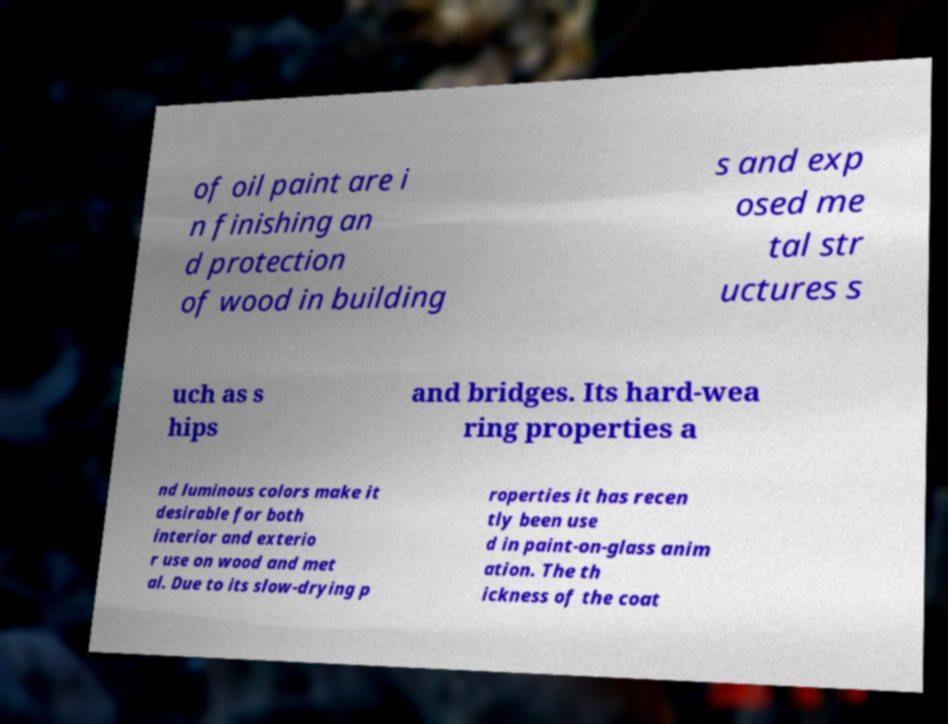What messages or text are displayed in this image? I need them in a readable, typed format. of oil paint are i n finishing an d protection of wood in building s and exp osed me tal str uctures s uch as s hips and bridges. Its hard-wea ring properties a nd luminous colors make it desirable for both interior and exterio r use on wood and met al. Due to its slow-drying p roperties it has recen tly been use d in paint-on-glass anim ation. The th ickness of the coat 